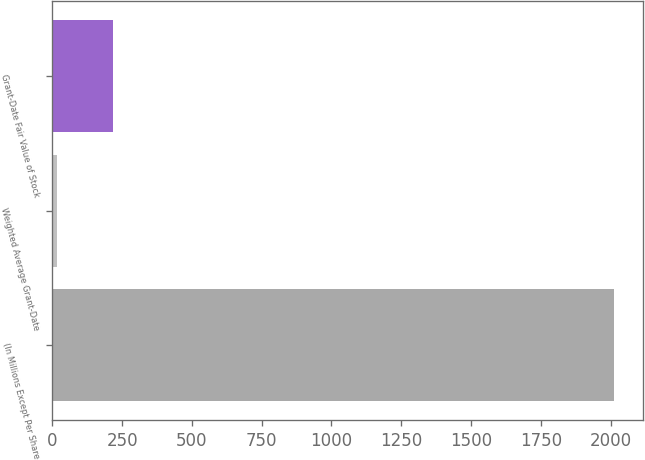Convert chart to OTSL. <chart><loc_0><loc_0><loc_500><loc_500><bar_chart><fcel>(In Millions Except Per Share<fcel>Weighted Average Grant-Date<fcel>Grant-Date Fair Value of Stock<nl><fcel>2014<fcel>16.22<fcel>216<nl></chart> 